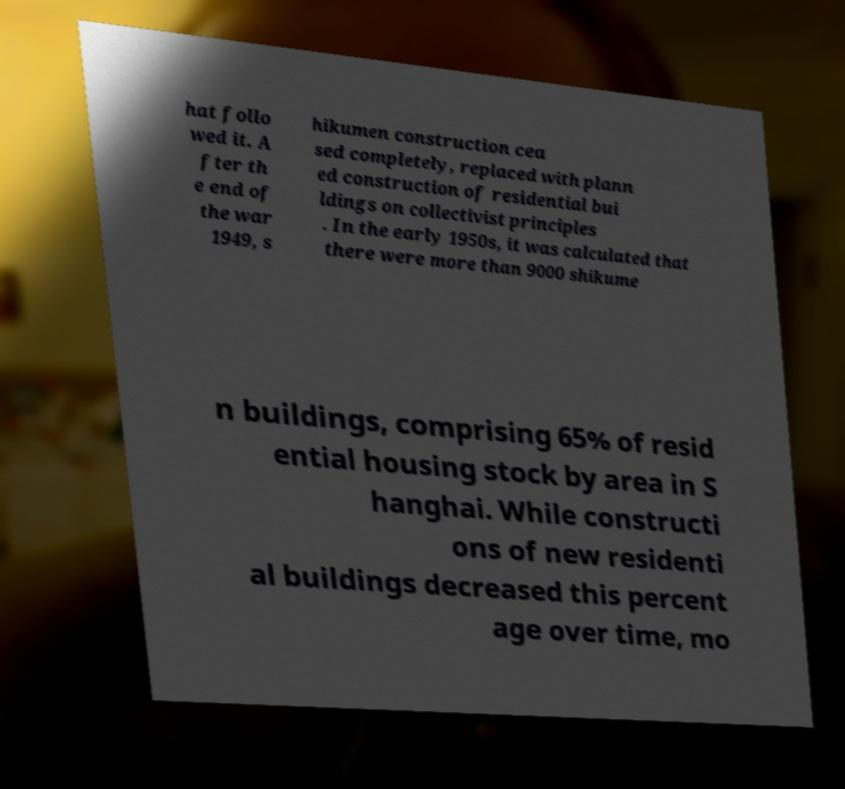There's text embedded in this image that I need extracted. Can you transcribe it verbatim? hat follo wed it. A fter th e end of the war 1949, s hikumen construction cea sed completely, replaced with plann ed construction of residential bui ldings on collectivist principles . In the early 1950s, it was calculated that there were more than 9000 shikume n buildings, comprising 65% of resid ential housing stock by area in S hanghai. While constructi ons of new residenti al buildings decreased this percent age over time, mo 